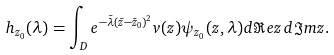Convert formula to latex. <formula><loc_0><loc_0><loc_500><loc_500>h _ { z _ { 0 } } ( \lambda ) = \int _ { D } e ^ { - \bar { \lambda } ( \bar { z } - \bar { z } _ { 0 } ) ^ { 2 } } v ( z ) \psi _ { z _ { 0 } } ( z , \lambda ) d \Re e z \, d \Im m z .</formula> 